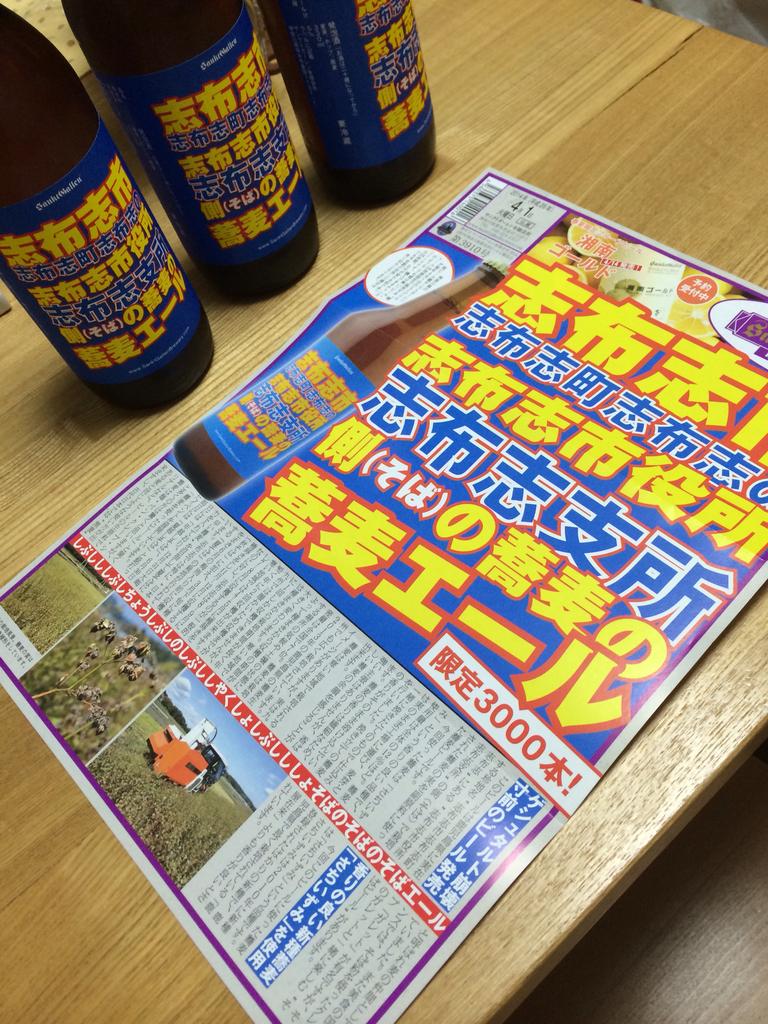How many copies are sold?
Your answer should be compact. 3000. What four digit number appears on this advertisement?
Your answer should be very brief. 3000. 